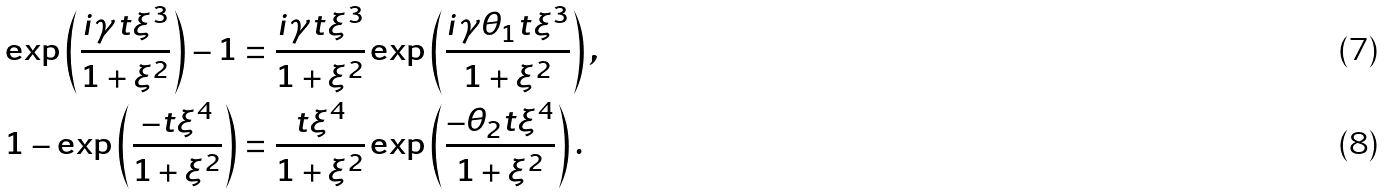Convert formula to latex. <formula><loc_0><loc_0><loc_500><loc_500>\exp \left ( \frac { i \gamma t \xi ^ { 3 } } { 1 + \xi ^ { 2 } } \right ) - 1 & = \frac { i \gamma t \xi ^ { 3 } } { 1 + \xi ^ { 2 } } \exp \left ( \frac { i \gamma \theta _ { 1 } t \xi ^ { 3 } } { 1 + \xi ^ { 2 } } \right ) , \\ 1 - \exp \left ( \frac { - t \xi ^ { 4 } } { 1 + \xi ^ { 2 } } \right ) & = \frac { t \xi ^ { 4 } } { 1 + \xi ^ { 2 } } \exp \left ( \frac { - \theta _ { 2 } t \xi ^ { 4 } } { 1 + \xi ^ { 2 } } \right ) .</formula> 